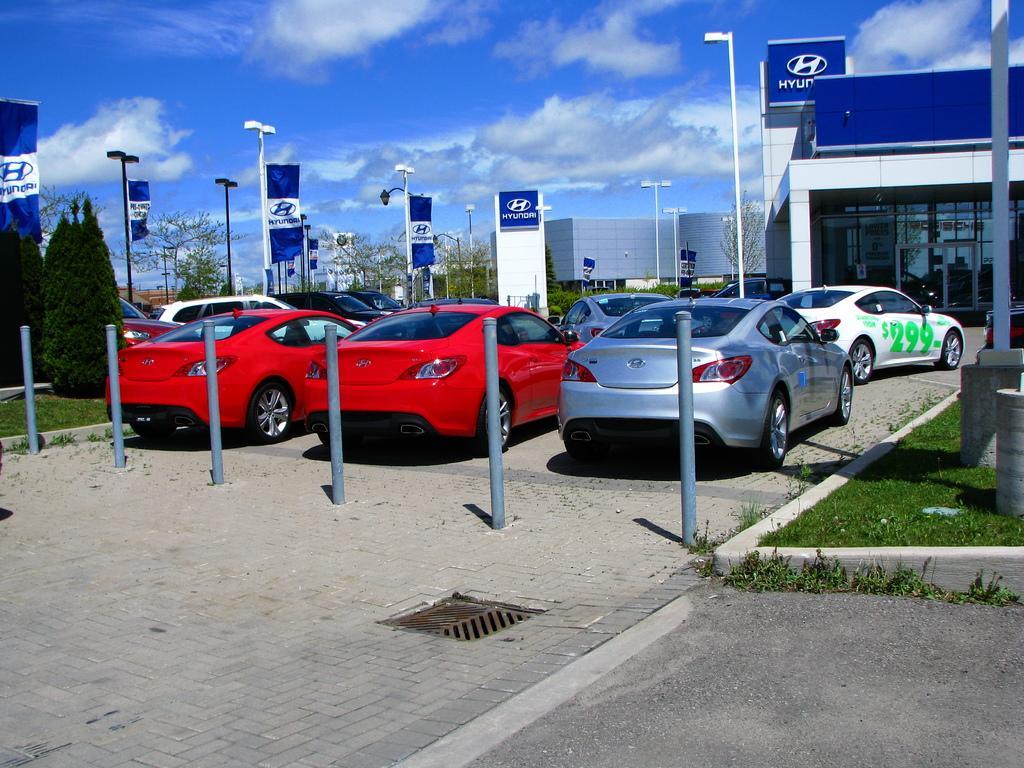How would you summarize this image in a sentence or two? In the foreground of this image, there is a pavement, road, few bollards, vehicles, grass on the right and a pole. In the background, there are few buildings, light poles, trees, flags, sky and the cloud. 